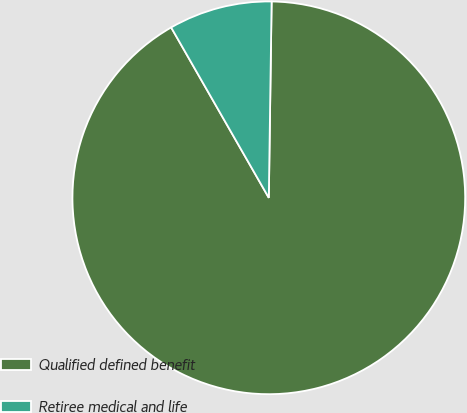Convert chart. <chart><loc_0><loc_0><loc_500><loc_500><pie_chart><fcel>Qualified defined benefit<fcel>Retiree medical and life<nl><fcel>91.49%<fcel>8.51%<nl></chart> 